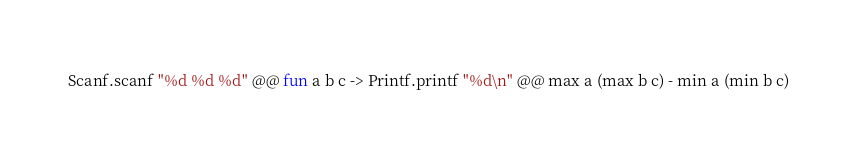<code> <loc_0><loc_0><loc_500><loc_500><_OCaml_>Scanf.scanf "%d %d %d" @@ fun a b c -> Printf.printf "%d\n" @@ max a (max b c) - min a (min b c)</code> 